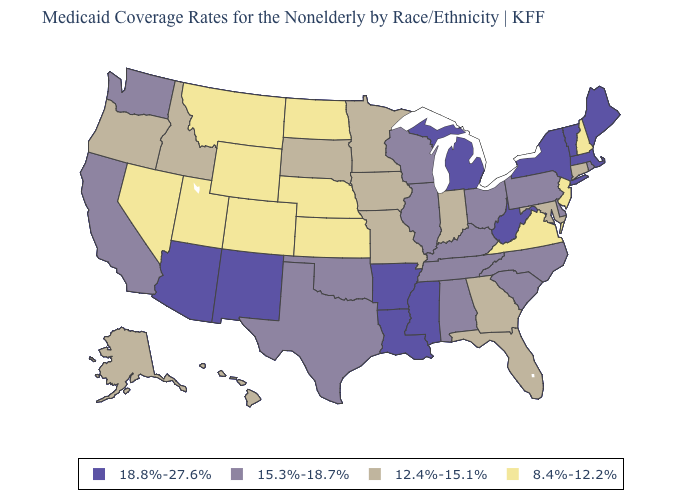What is the value of Nevada?
Short answer required. 8.4%-12.2%. Among the states that border Oregon , which have the lowest value?
Answer briefly. Nevada. Name the states that have a value in the range 12.4%-15.1%?
Concise answer only. Alaska, Connecticut, Florida, Georgia, Hawaii, Idaho, Indiana, Iowa, Maryland, Minnesota, Missouri, Oregon, South Dakota. Name the states that have a value in the range 18.8%-27.6%?
Quick response, please. Arizona, Arkansas, Louisiana, Maine, Massachusetts, Michigan, Mississippi, New Mexico, New York, Vermont, West Virginia. Among the states that border California , which have the highest value?
Be succinct. Arizona. What is the lowest value in states that border Tennessee?
Short answer required. 8.4%-12.2%. What is the highest value in the USA?
Write a very short answer. 18.8%-27.6%. What is the highest value in the South ?
Short answer required. 18.8%-27.6%. What is the value of New Mexico?
Short answer required. 18.8%-27.6%. Which states have the lowest value in the USA?
Short answer required. Colorado, Kansas, Montana, Nebraska, Nevada, New Hampshire, New Jersey, North Dakota, Utah, Virginia, Wyoming. Among the states that border Ohio , does Kentucky have the highest value?
Concise answer only. No. What is the lowest value in the MidWest?
Be succinct. 8.4%-12.2%. Name the states that have a value in the range 8.4%-12.2%?
Be succinct. Colorado, Kansas, Montana, Nebraska, Nevada, New Hampshire, New Jersey, North Dakota, Utah, Virginia, Wyoming. Name the states that have a value in the range 8.4%-12.2%?
Quick response, please. Colorado, Kansas, Montana, Nebraska, Nevada, New Hampshire, New Jersey, North Dakota, Utah, Virginia, Wyoming. 